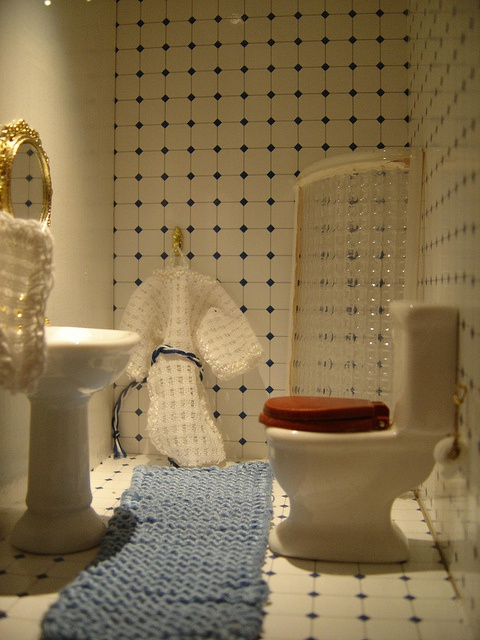Describe the objects in this image and their specific colors. I can see toilet in olive, tan, and gray tones and sink in olive, gray, and beige tones in this image. 